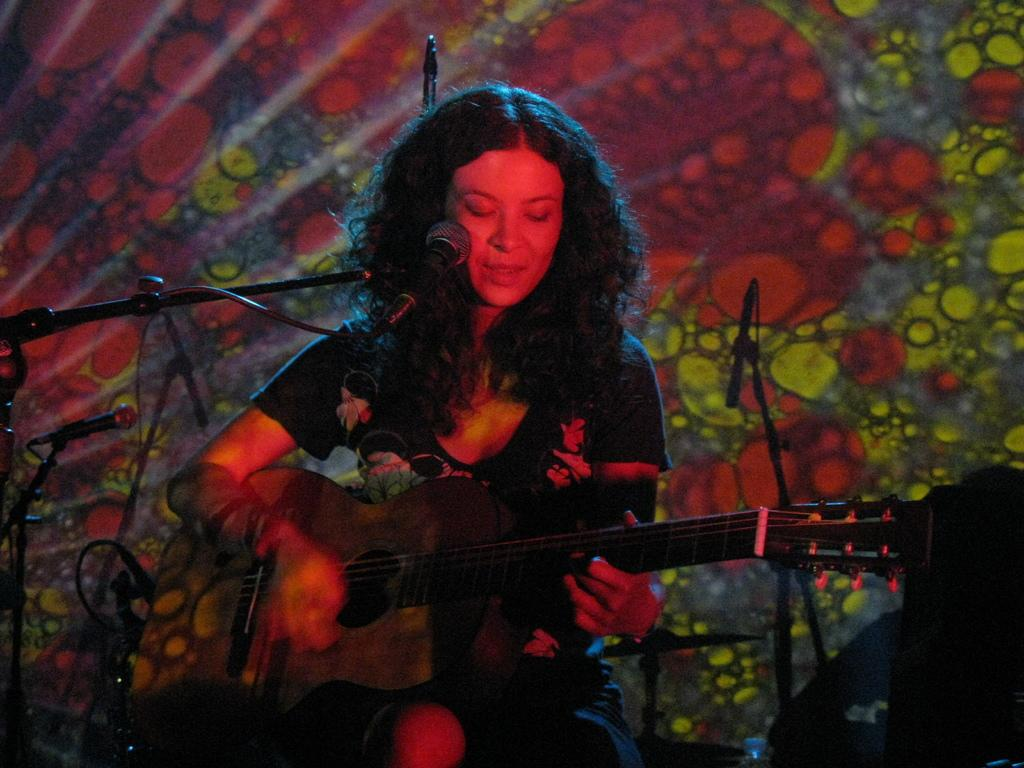Who is the main subject in the image? There is a woman in the image. What is the woman doing in the image? The woman is sitting on a chair and playing a guitar. What object is present in the image that is typically used for amplifying sound? There is a microphone in the image. Can you see an airplane flying in the background of the image? No, there is no airplane visible in the image. What type of pin is the woman wearing on her shirt in the image? There is no pin visible on the woman's shirt in the image. 